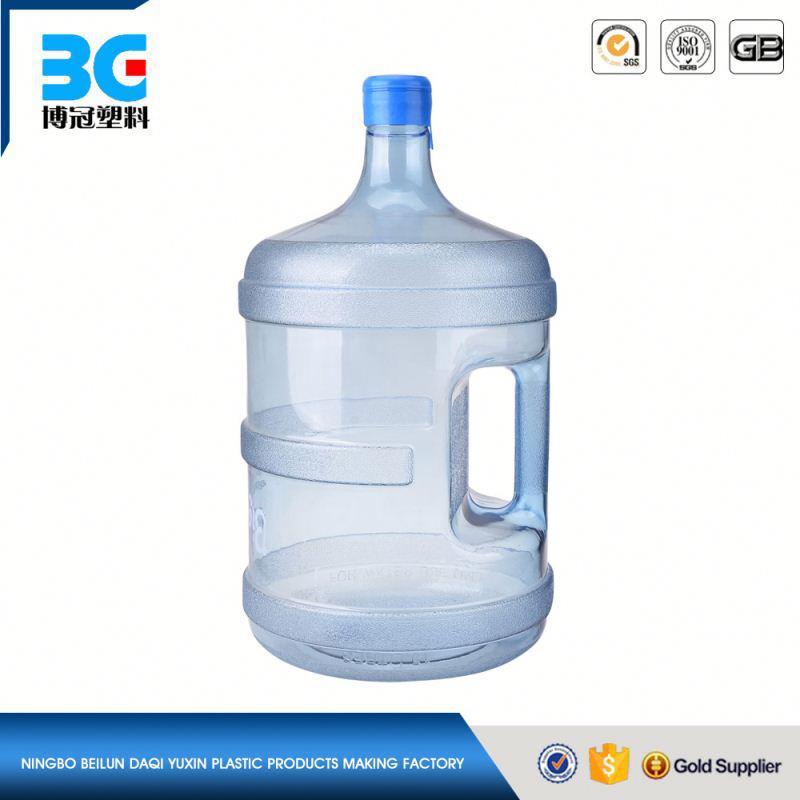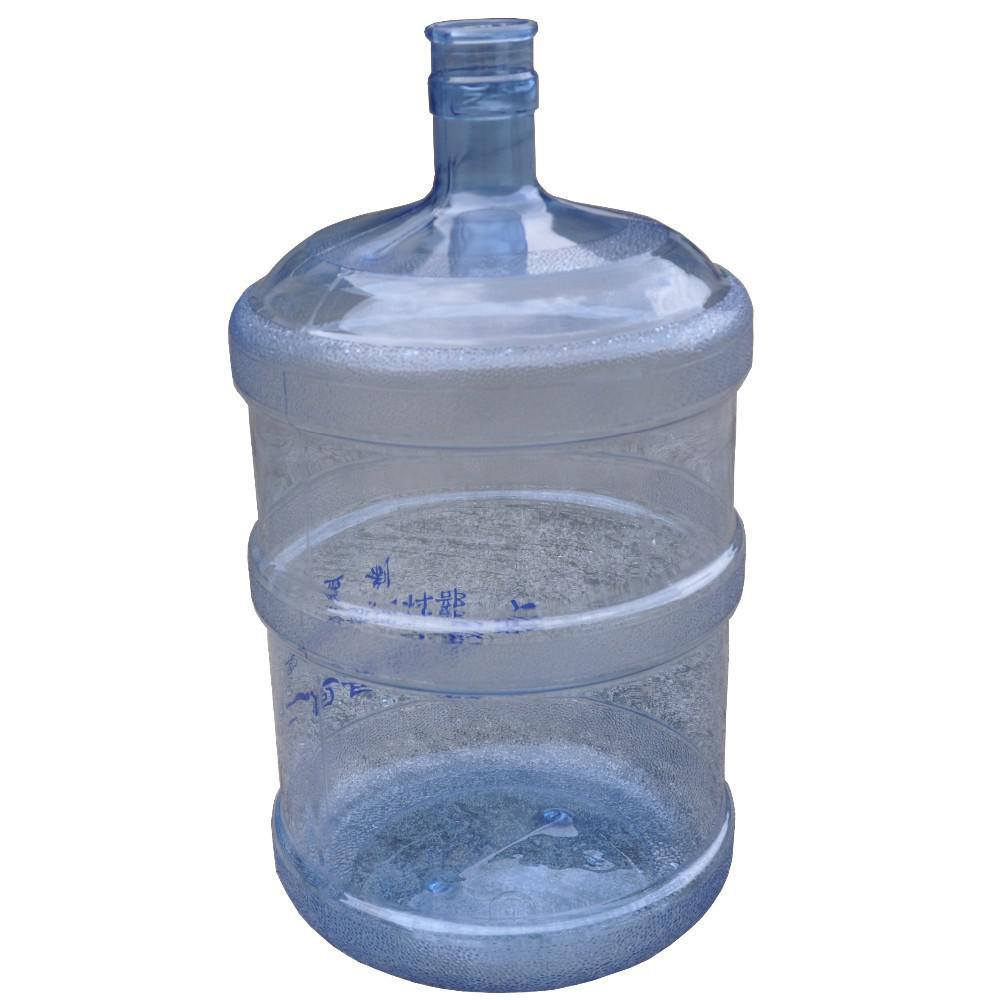The first image is the image on the left, the second image is the image on the right. For the images displayed, is the sentence "All images feature a single plastic jug." factually correct? Answer yes or no. Yes. The first image is the image on the left, the second image is the image on the right. For the images shown, is this caption "Each image contains a single upright blue-translucent water jug." true? Answer yes or no. Yes. 